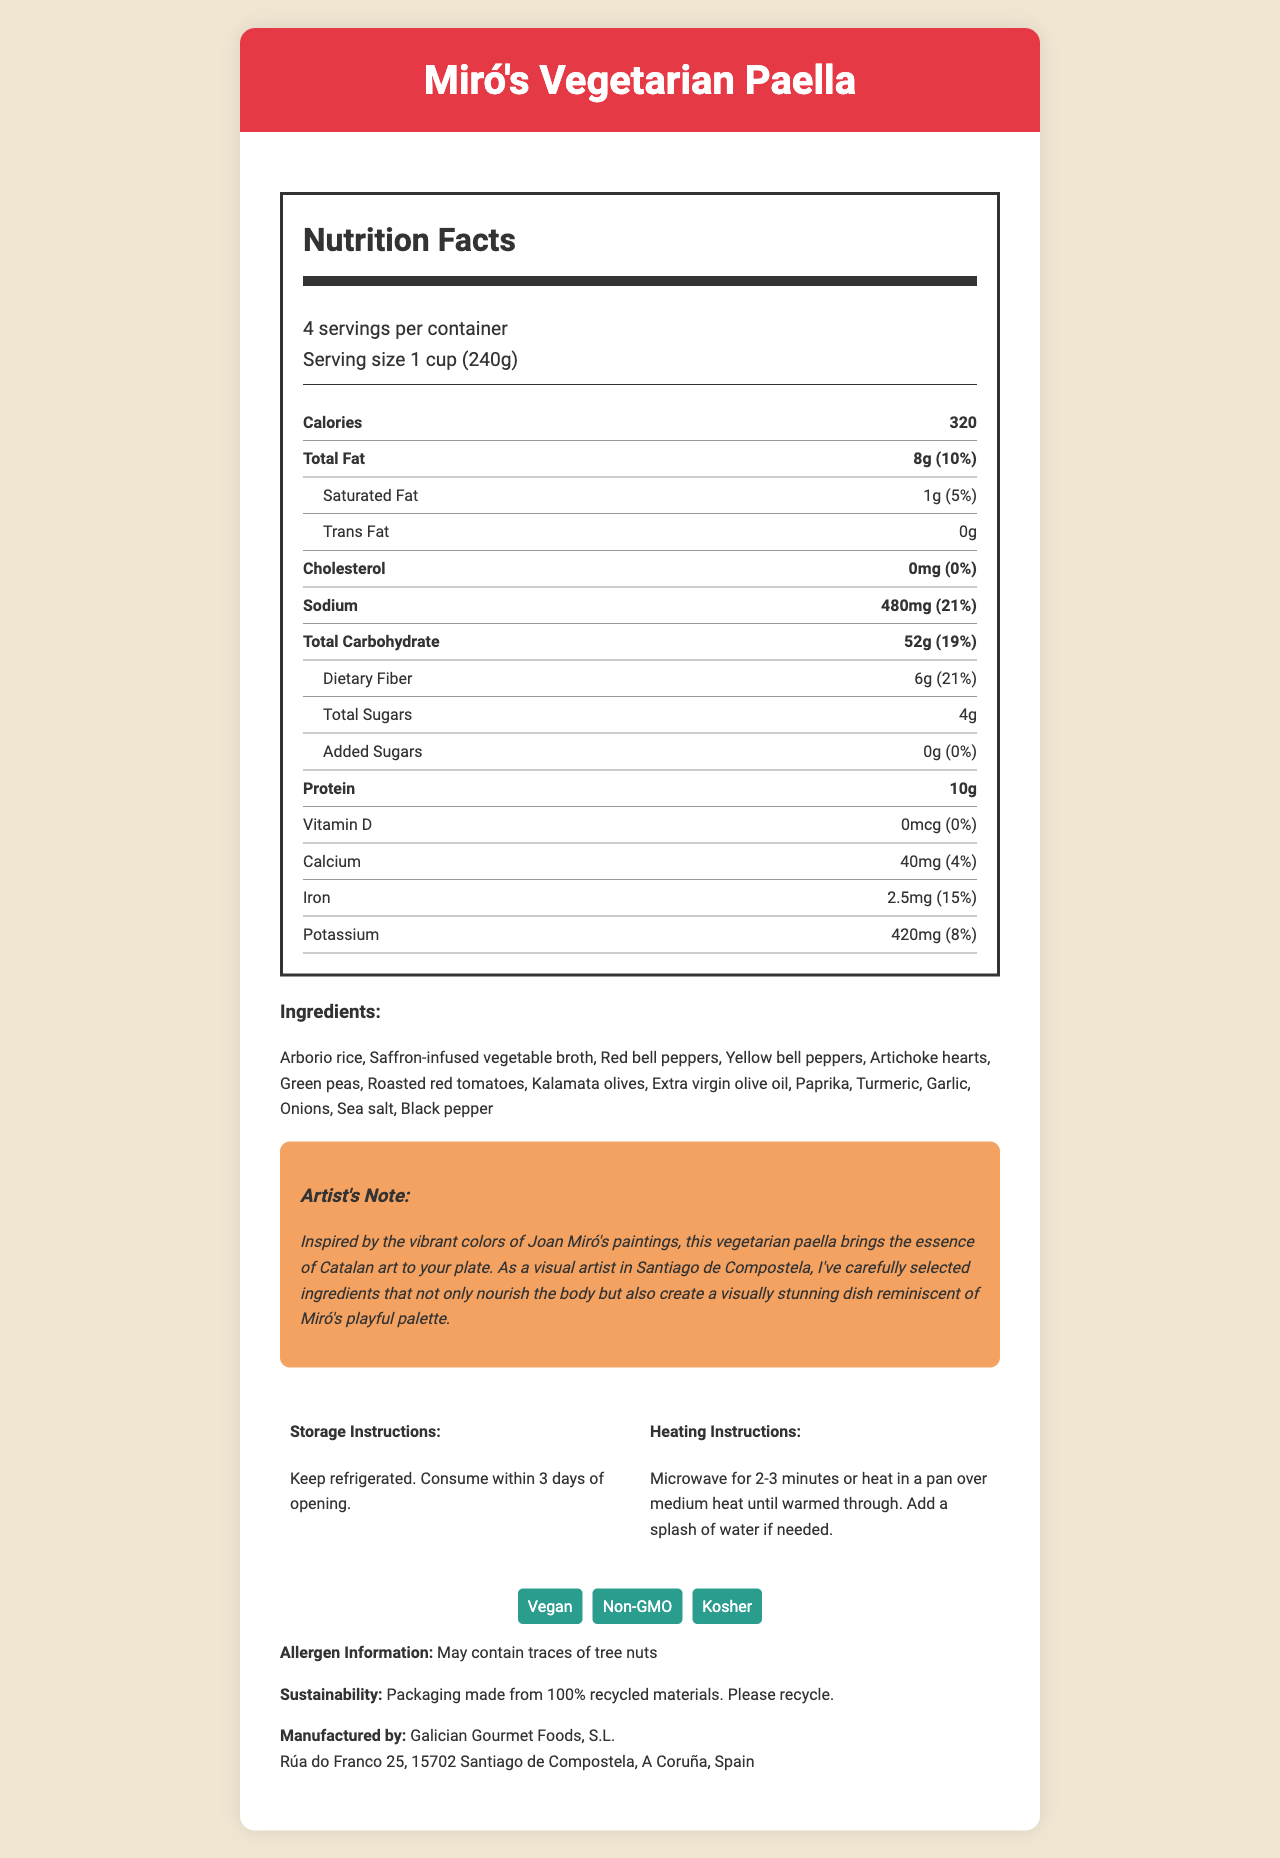what is the product name? The product name is clearly stated in the header of the document, which says "Nutrition Facts: Miró's Vegetarian Paella."
Answer: Miró's Vegetarian Paella how many servings are in one container? The serving information states "4 servings per container."
Answer: 4 how much total fat is in one serving? The nutrition label under "Total Fat" indicates that one serving contains 8 grams of total fat.
Answer: 8g what is the daily value percentage of sodium for one serving? The nutrition label shows that one serving contains 480mg of sodium, which is 21% of the daily value.
Answer: 21% what are the main ingredients? The list of ingredients is provided in the document under the "Ingredients" section.
Answer: Arborio rice, Saffron-infused vegetable broth, Red bell peppers, Yellow bell peppers, Artichoke hearts, Green peas, Roasted red tomatoes, Kalamata olives, Extra virgin olive oil, Paprika, Turmeric, Garlic, Onions, Sea salt, Black pepper which certification does this product have? A. Organic B. Non-GMO C. Gluten-Free The product certifications listed in the document include "Vegan," "Non-GMO," and "Kosher." Non-GMO is the correct answer.
Answer: B which nutrient contributes 5% of the daily value per serving? A. Dietary Fiber B. Saturated Fat C. Protein D. Calcium Saturated fat contributes 5% of the daily value per serving, according to the nutrition label.
Answer: B does the product contain any allergens? The document states that the product "May contain traces of tree nuts" under allergen information.
Answer: Yes is this product suitable for vegans? The document indicates that the product has a "Vegan" certification.
Answer: Yes describe the main idea of the document. The document serves to inform consumers about the nutritional content, ingredients, certifications, and preparation methods of the product, emphasizing its visual and culinary appeal inspired by Miró's art.
Answer: The document provides comprehensive nutritional information, ingredients, certification, and preparation instructions for Miró's Vegetarian Paella, a colorful vegetarian dish inspired by Joan Miró's artwork. It highlights the product's vegan certification, potential allergens, and sustainability information while also noting the artistic inspiration behind the dish. where can I purchase this product? The document does not provide details on where to purchase the product, only the manufacturer's address is given.
Answer: Not enough information 